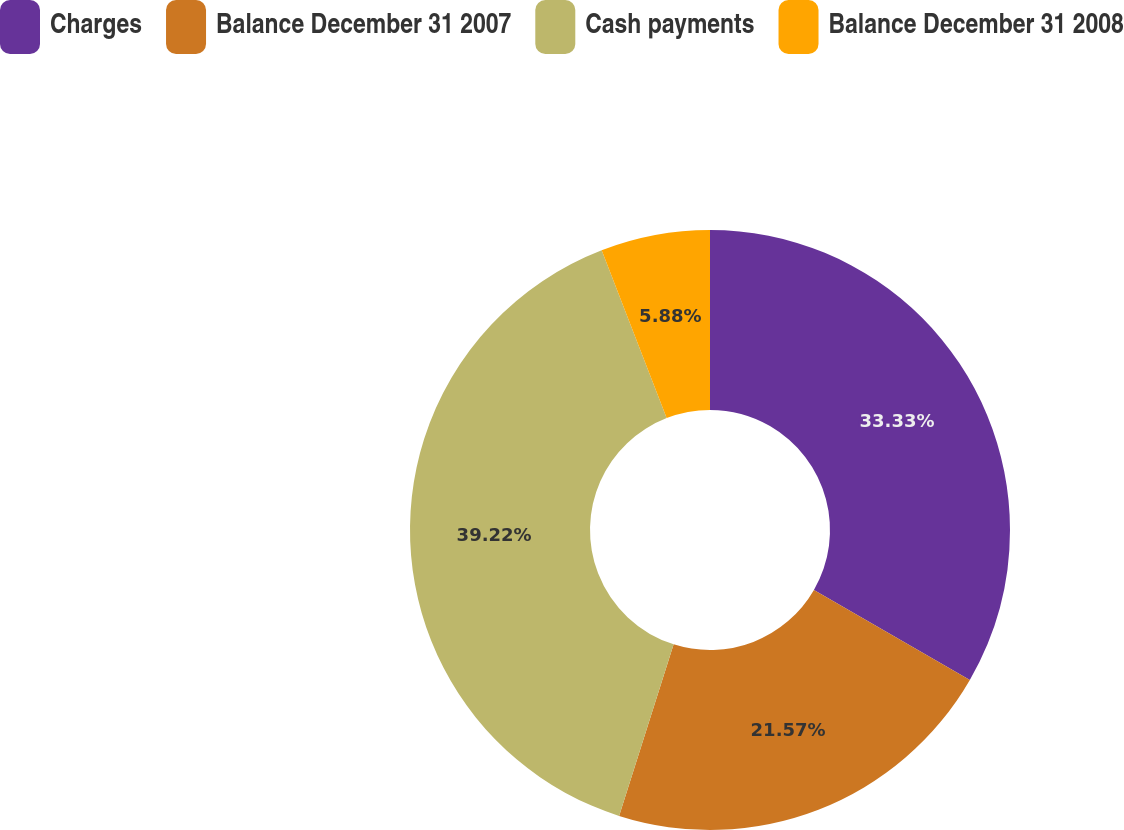<chart> <loc_0><loc_0><loc_500><loc_500><pie_chart><fcel>Charges<fcel>Balance December 31 2007<fcel>Cash payments<fcel>Balance December 31 2008<nl><fcel>33.33%<fcel>21.57%<fcel>39.22%<fcel>5.88%<nl></chart> 